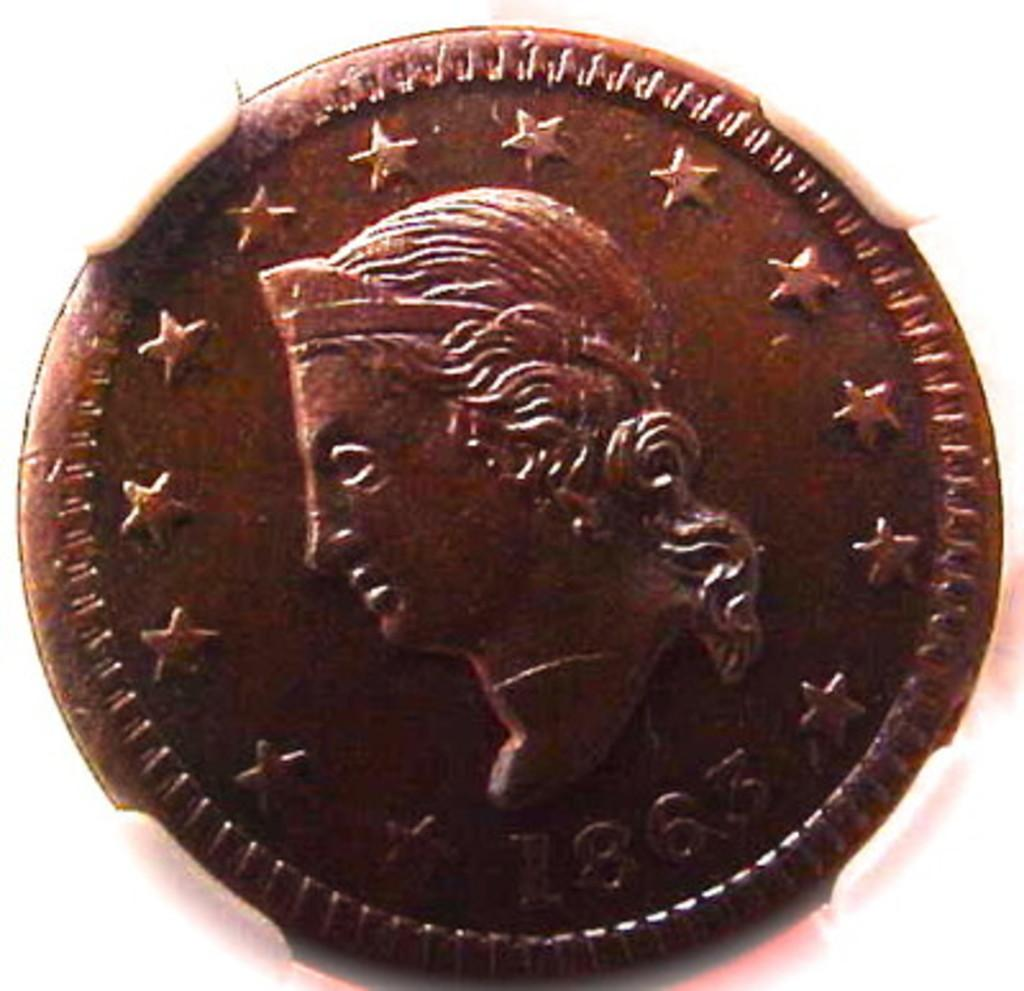<image>
Offer a succinct explanation of the picture presented. A bronze coin from 1863 with a face on it and a bunch of stars. 